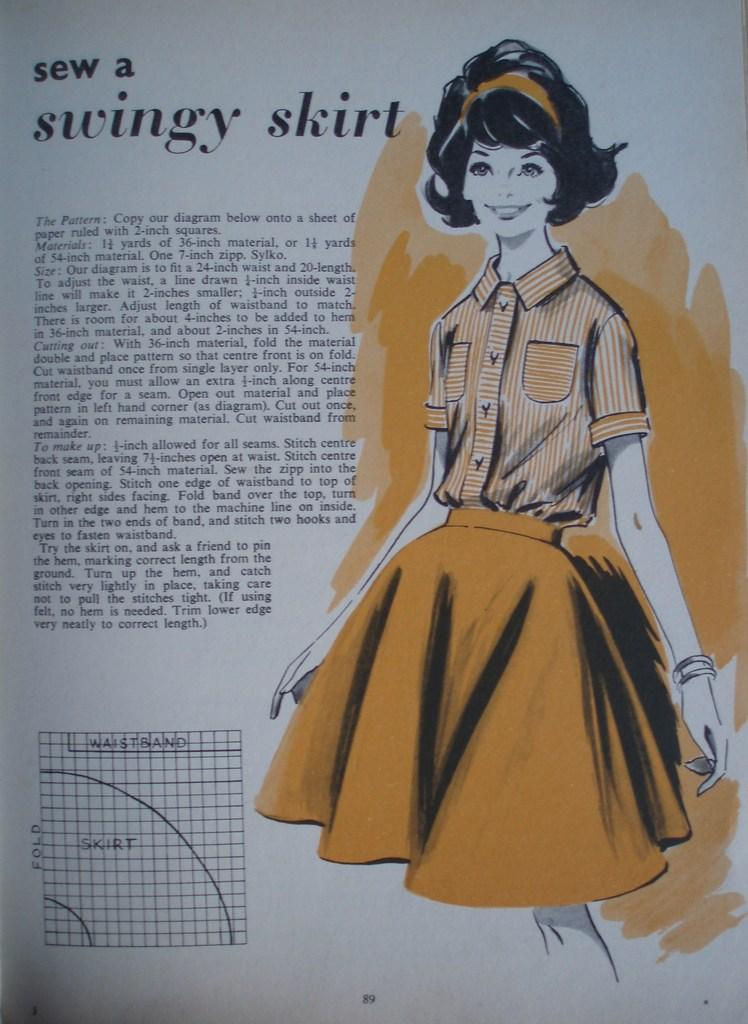Who is the main subject in the image? There is a woman in the image. What is the woman doing in the image? The woman is standing. What type of clothing is the woman wearing on her upper body? The woman is wearing a shirt. What type of clothing is the woman wearing on her lower body? The woman is wearing shorts. What type of fruit is the woman holding in the image? There is no fruit present in the image. How many berries can be seen on the woman's shirt in the image? There are no berries visible on the woman's shirt in the image. 